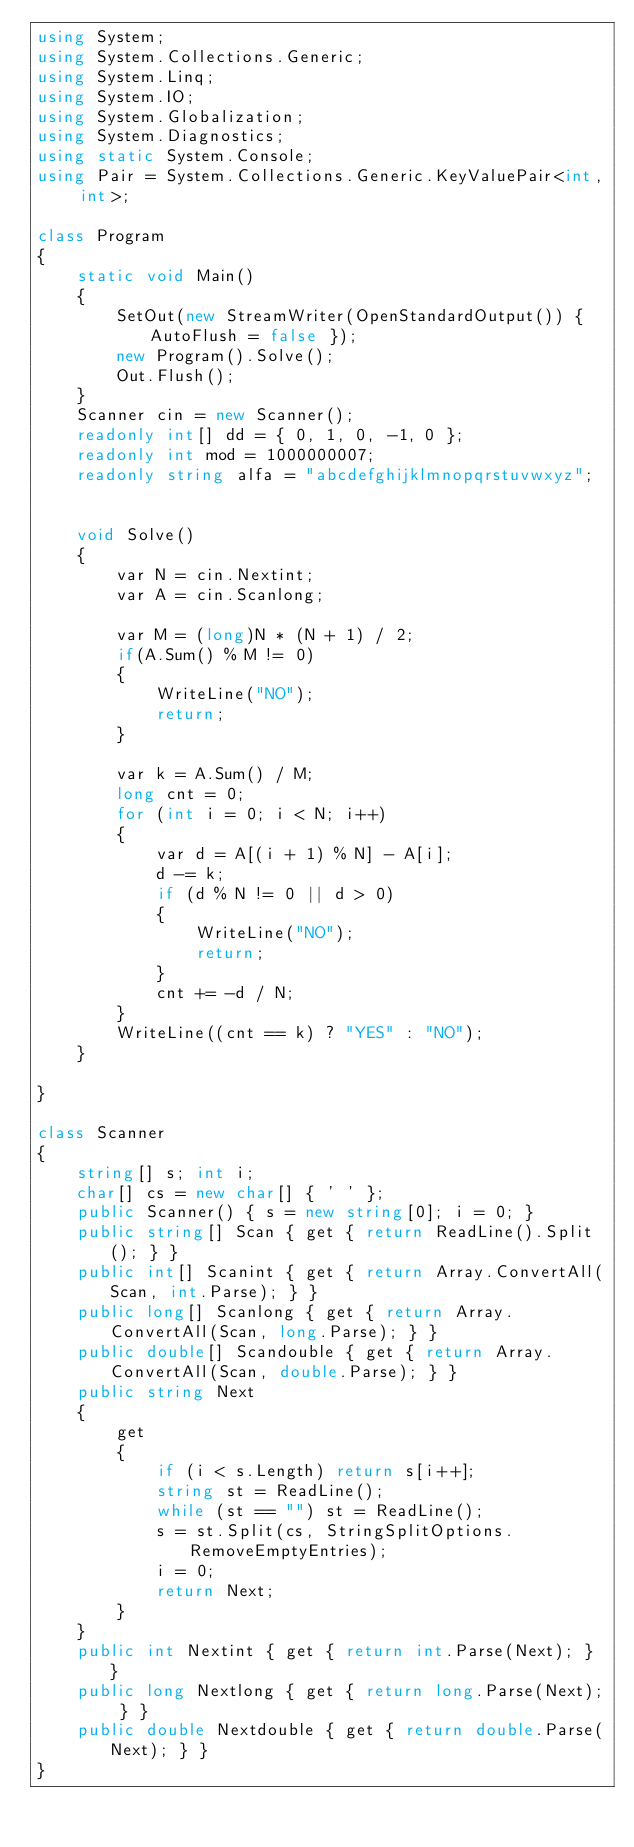<code> <loc_0><loc_0><loc_500><loc_500><_C#_>using System;
using System.Collections.Generic;
using System.Linq;
using System.IO;
using System.Globalization;
using System.Diagnostics;
using static System.Console;
using Pair = System.Collections.Generic.KeyValuePair<int, int>;

class Program
{
    static void Main()
    {
        SetOut(new StreamWriter(OpenStandardOutput()) { AutoFlush = false });
        new Program().Solve();
        Out.Flush();
    }
    Scanner cin = new Scanner();
    readonly int[] dd = { 0, 1, 0, -1, 0 };
    readonly int mod = 1000000007;
    readonly string alfa = "abcdefghijklmnopqrstuvwxyz";


    void Solve()
    {
        var N = cin.Nextint;
        var A = cin.Scanlong;

        var M = (long)N * (N + 1) / 2;
        if(A.Sum() % M != 0)
        {
            WriteLine("NO");
            return;
        }

        var k = A.Sum() / M;
        long cnt = 0;
        for (int i = 0; i < N; i++)
        {
            var d = A[(i + 1) % N] - A[i];
            d -= k;
            if (d % N != 0 || d > 0)
            {
                WriteLine("NO");
                return;
            }
            cnt += -d / N;
        }
        WriteLine((cnt == k) ? "YES" : "NO");
    }

}

class Scanner
{
    string[] s; int i;
    char[] cs = new char[] { ' ' };
    public Scanner() { s = new string[0]; i = 0; }
    public string[] Scan { get { return ReadLine().Split(); } }
    public int[] Scanint { get { return Array.ConvertAll(Scan, int.Parse); } }
    public long[] Scanlong { get { return Array.ConvertAll(Scan, long.Parse); } }
    public double[] Scandouble { get { return Array.ConvertAll(Scan, double.Parse); } }
    public string Next
    {
        get
        {
            if (i < s.Length) return s[i++];
            string st = ReadLine();
            while (st == "") st = ReadLine();
            s = st.Split(cs, StringSplitOptions.RemoveEmptyEntries);
            i = 0;
            return Next;
        }
    }
    public int Nextint { get { return int.Parse(Next); } }
    public long Nextlong { get { return long.Parse(Next); } }
    public double Nextdouble { get { return double.Parse(Next); } }
}</code> 